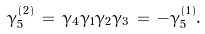<formula> <loc_0><loc_0><loc_500><loc_500>\gamma _ { 5 } ^ { ( 2 ) } \, = \, \gamma _ { 4 } \gamma _ { 1 } \gamma _ { 2 } \gamma _ { 3 } \, = \, - \gamma _ { 5 } ^ { ( 1 ) } .</formula> 